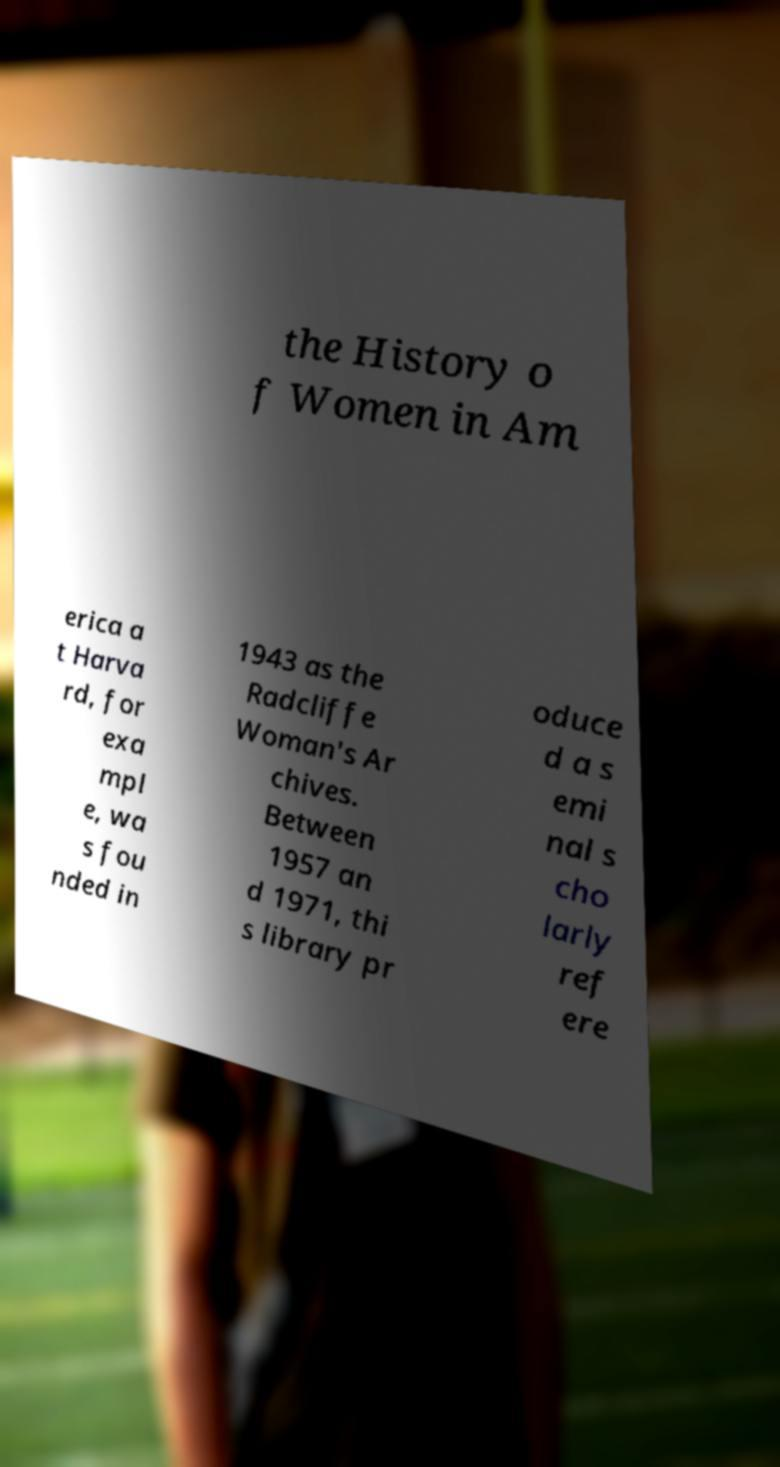For documentation purposes, I need the text within this image transcribed. Could you provide that? the History o f Women in Am erica a t Harva rd, for exa mpl e, wa s fou nded in 1943 as the Radcliffe Woman's Ar chives. Between 1957 an d 1971, thi s library pr oduce d a s emi nal s cho larly ref ere 